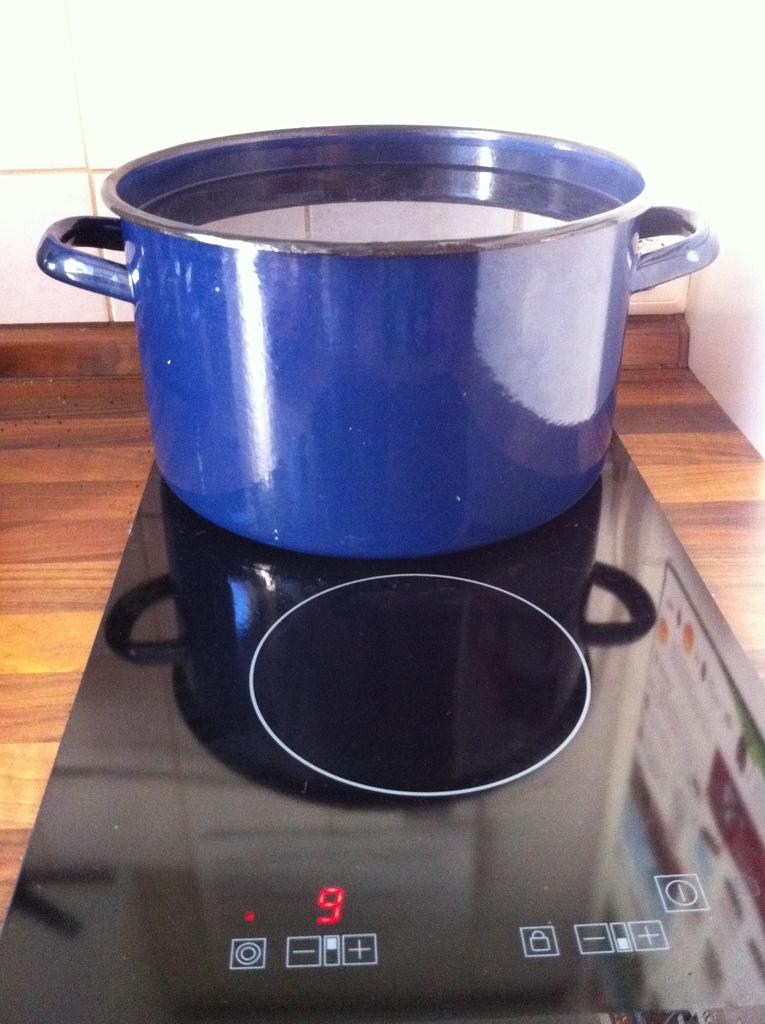<image>
Relay a brief, clear account of the picture shown. a blue pot on a black cooker with the temp set at 9 